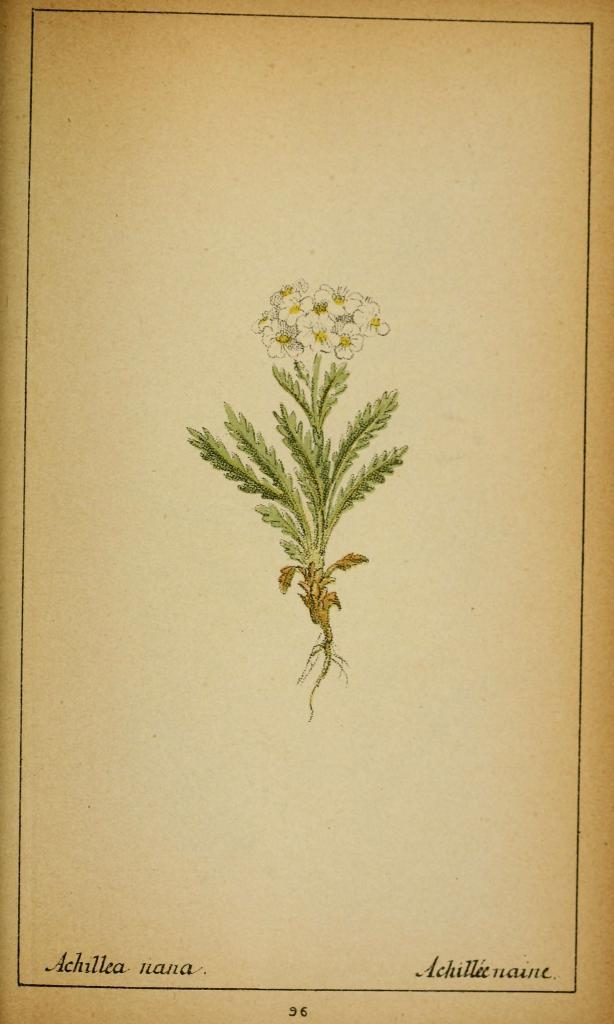What is the main subject of the image? The main subject of the image is a flower plant. Is there any text present in the image? Yes, there is text written on the image. What type of liquid is being poured on the flower plant in the image? There is no liquid being poured on the flower plant in the image. How much money is visible in the image? There is no money present in the image. 